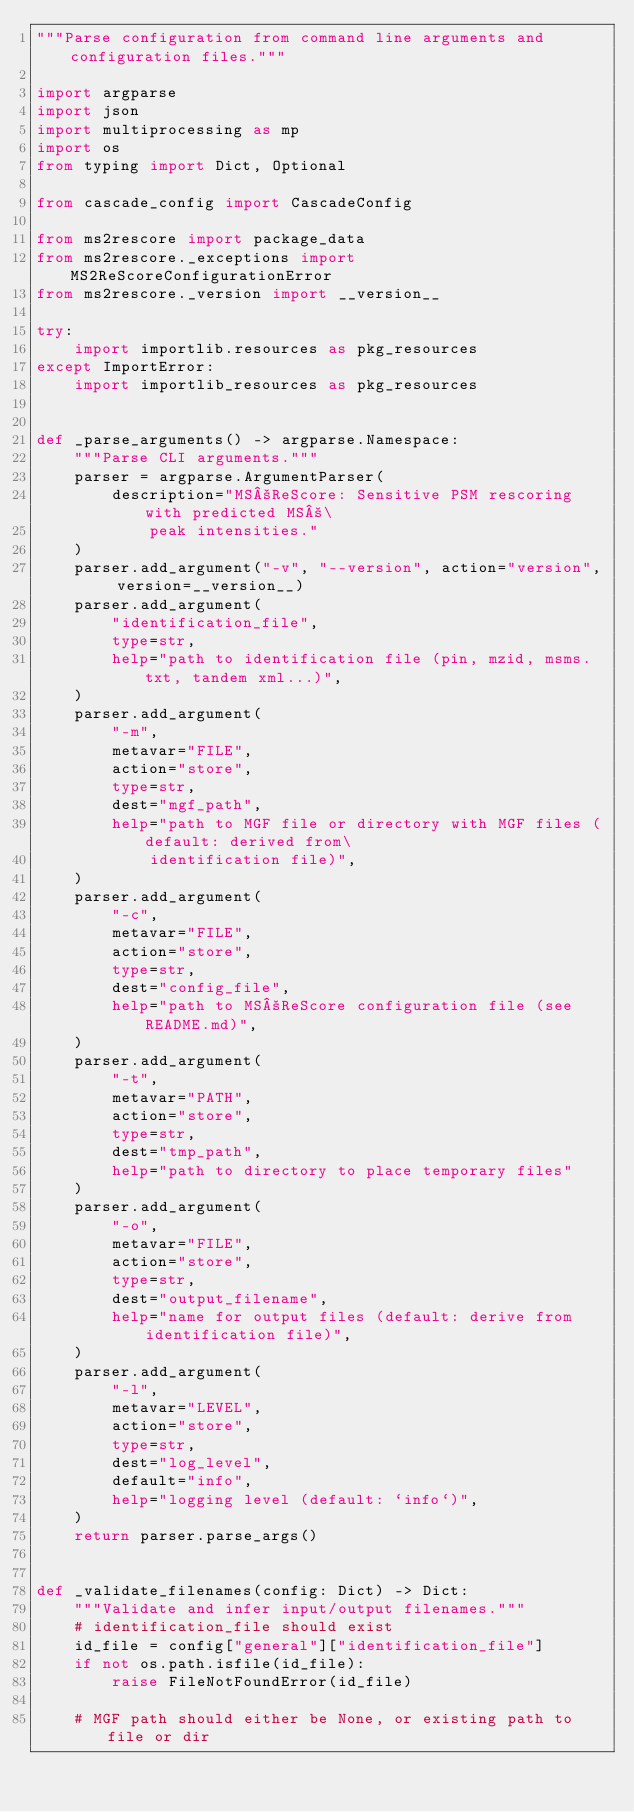<code> <loc_0><loc_0><loc_500><loc_500><_Python_>"""Parse configuration from command line arguments and configuration files."""

import argparse
import json
import multiprocessing as mp
import os
from typing import Dict, Optional

from cascade_config import CascadeConfig

from ms2rescore import package_data
from ms2rescore._exceptions import MS2ReScoreConfigurationError
from ms2rescore._version import __version__

try:
    import importlib.resources as pkg_resources
except ImportError:
    import importlib_resources as pkg_resources


def _parse_arguments() -> argparse.Namespace:
    """Parse CLI arguments."""
    parser = argparse.ArgumentParser(
        description="MS²ReScore: Sensitive PSM rescoring with predicted MS²\
            peak intensities."
    )
    parser.add_argument("-v", "--version", action="version", version=__version__)
    parser.add_argument(
        "identification_file",
        type=str,
        help="path to identification file (pin, mzid, msms.txt, tandem xml...)",
    )
    parser.add_argument(
        "-m",
        metavar="FILE",
        action="store",
        type=str,
        dest="mgf_path",
        help="path to MGF file or directory with MGF files (default: derived from\
            identification file)",
    )
    parser.add_argument(
        "-c",
        metavar="FILE",
        action="store",
        type=str,
        dest="config_file",
        help="path to MS²ReScore configuration file (see README.md)",
    )
    parser.add_argument(
        "-t",
        metavar="PATH",
        action="store",
        type=str,
        dest="tmp_path",
        help="path to directory to place temporary files"
    )
    parser.add_argument(
        "-o",
        metavar="FILE",
        action="store",
        type=str,
        dest="output_filename",
        help="name for output files (default: derive from identification file)",
    )
    parser.add_argument(
        "-l",
        metavar="LEVEL",
        action="store",
        type=str,
        dest="log_level",
        default="info",
        help="logging level (default: `info`)",
    )
    return parser.parse_args()


def _validate_filenames(config: Dict) -> Dict:
    """Validate and infer input/output filenames."""
    # identification_file should exist
    id_file = config["general"]["identification_file"]
    if not os.path.isfile(id_file):
        raise FileNotFoundError(id_file)

    # MGF path should either be None, or existing path to file or dir</code> 